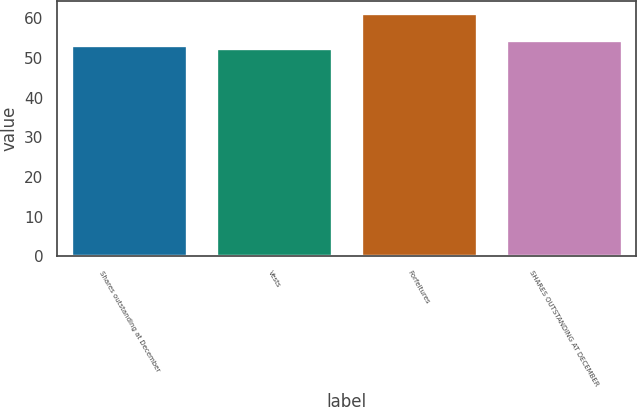Convert chart. <chart><loc_0><loc_0><loc_500><loc_500><bar_chart><fcel>Shares outstanding at December<fcel>Vests<fcel>Forfeitures<fcel>SHARES OUTSTANDING AT DECEMBER<nl><fcel>53.33<fcel>52.44<fcel>61.33<fcel>54.44<nl></chart> 